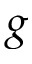Convert formula to latex. <formula><loc_0><loc_0><loc_500><loc_500>g</formula> 